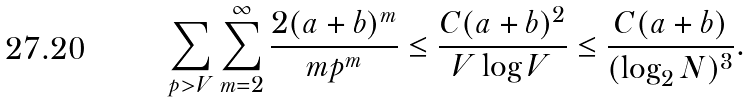Convert formula to latex. <formula><loc_0><loc_0><loc_500><loc_500>\sum _ { p > V } \sum ^ { \infty } _ { m = 2 } \frac { 2 ( a + b ) ^ { m } } { m p ^ { m } } \leq \frac { C ( a + b ) ^ { 2 } } { V \log V } \leq \frac { C ( a + b ) } { ( \log _ { 2 } N ) ^ { 3 } } .</formula> 